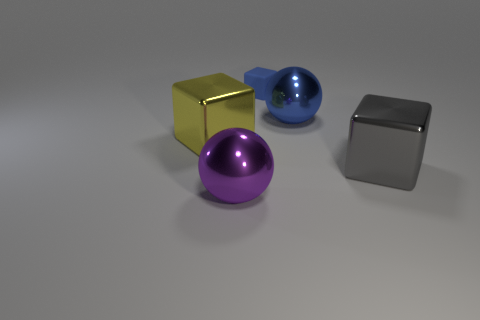Subtract all metal blocks. How many blocks are left? 1 Add 2 tiny blue things. How many objects exist? 7 Subtract all blue cubes. How many cubes are left? 2 Subtract all spheres. How many objects are left? 3 Subtract all purple blocks. Subtract all gray spheres. How many blocks are left? 3 Subtract all large cyan matte cylinders. Subtract all blue things. How many objects are left? 3 Add 2 gray metallic things. How many gray metallic things are left? 3 Add 4 big blue metallic objects. How many big blue metallic objects exist? 5 Subtract 0 gray balls. How many objects are left? 5 